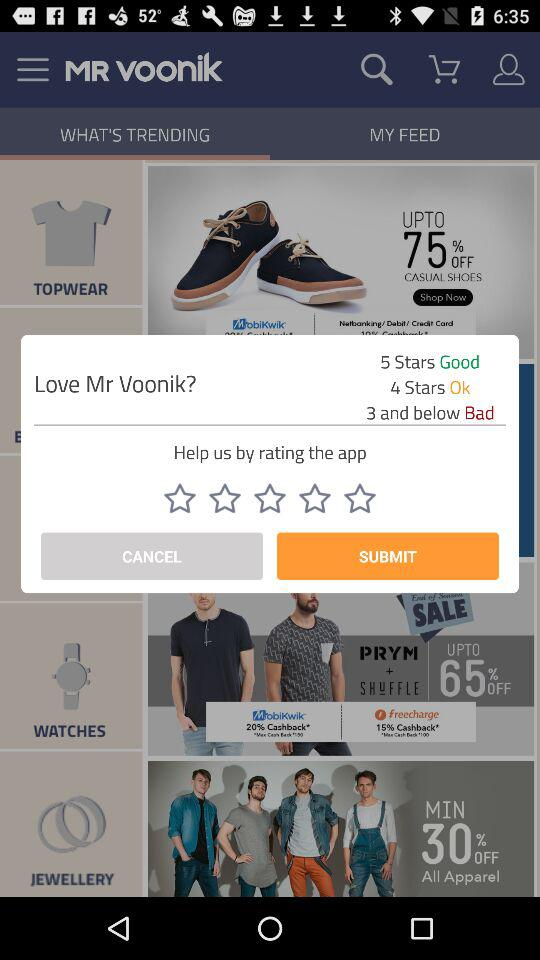What is the rating for bad? The rating for bad is 3 and below. 